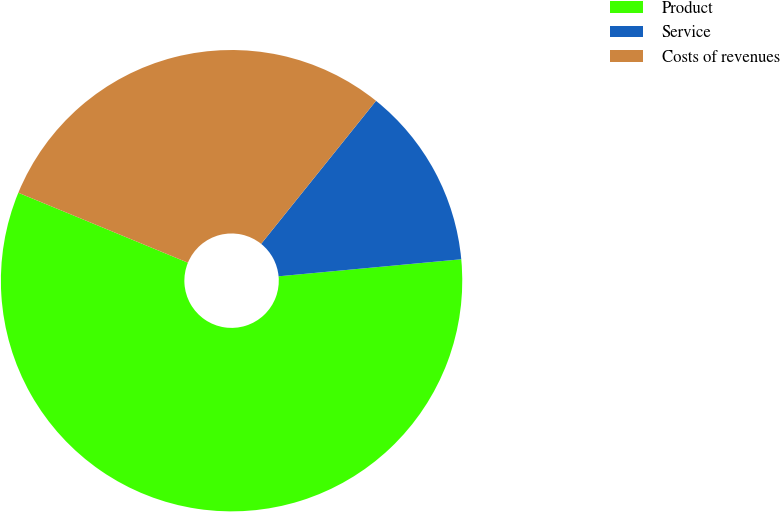<chart> <loc_0><loc_0><loc_500><loc_500><pie_chart><fcel>Product<fcel>Service<fcel>Costs of revenues<nl><fcel>57.7%<fcel>12.75%<fcel>29.54%<nl></chart> 